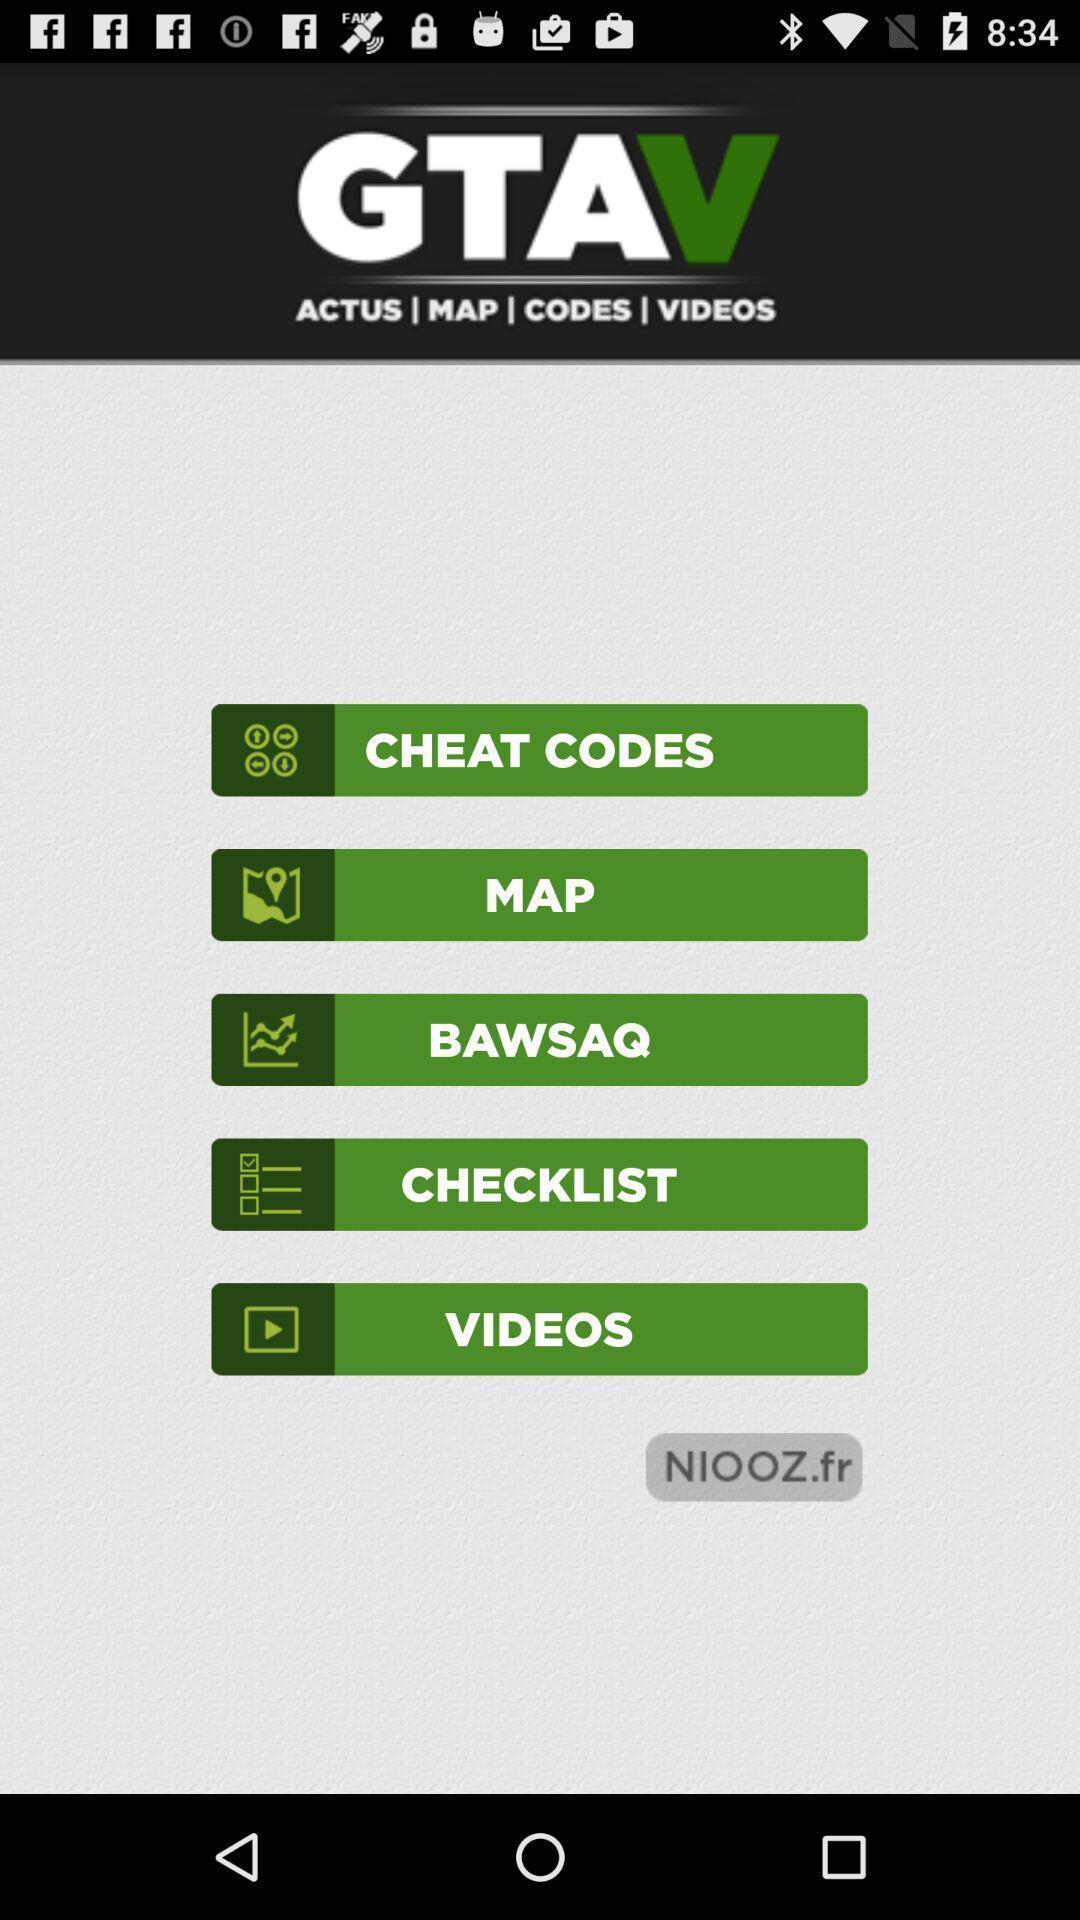What is the overall content of this screenshot? Welcome page of a gaming app. 